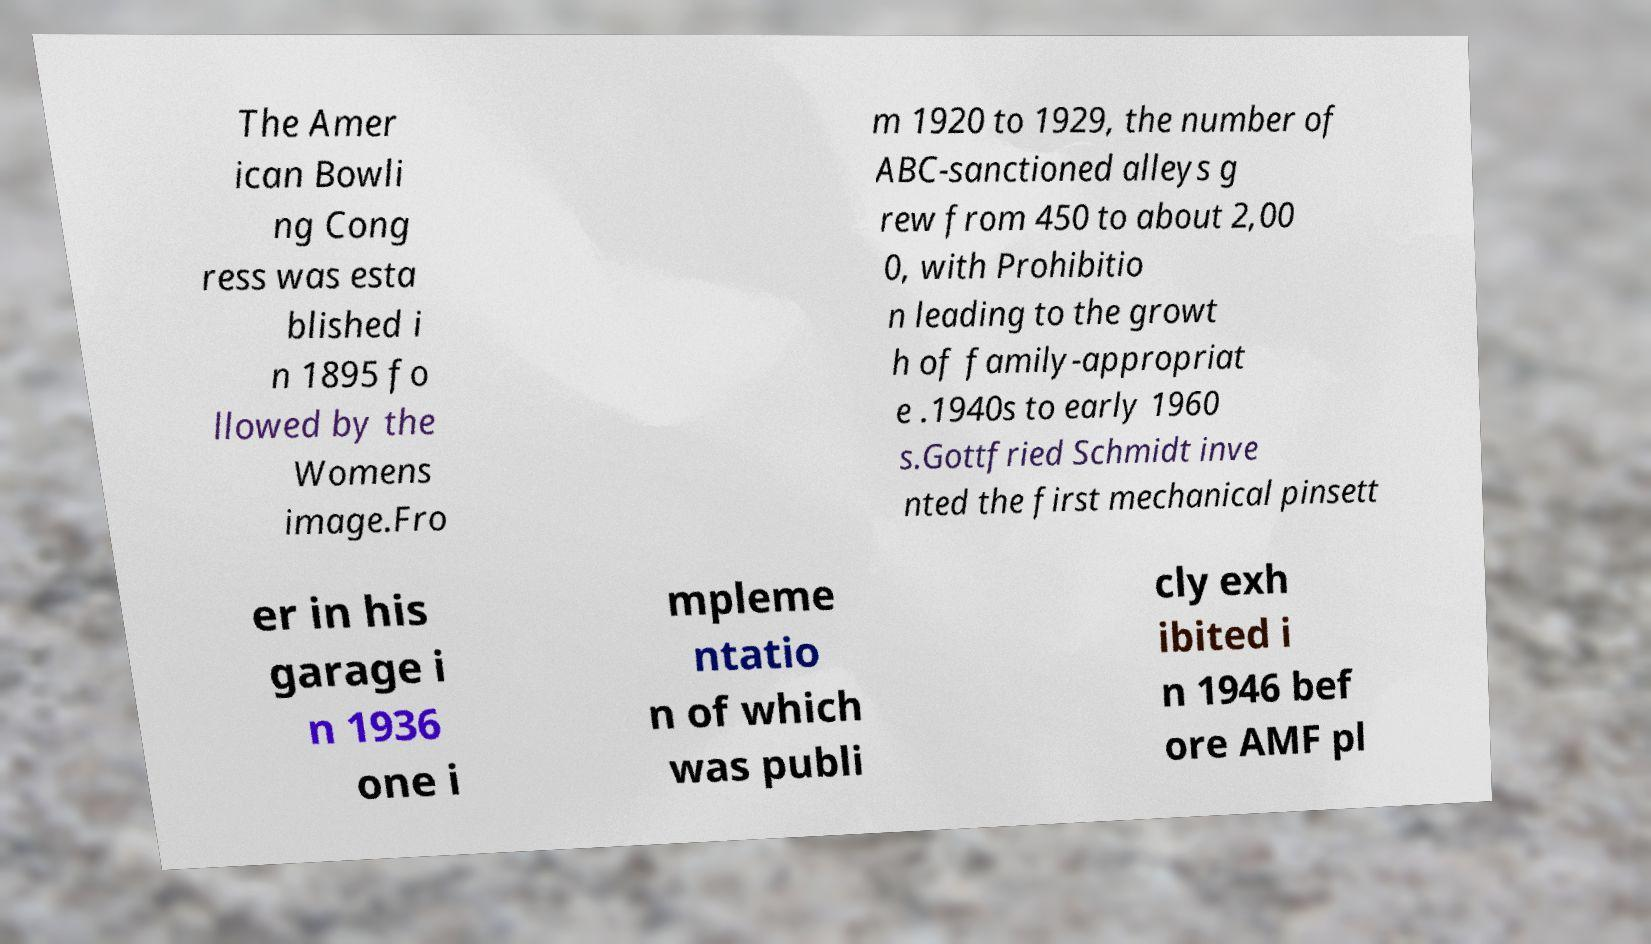I need the written content from this picture converted into text. Can you do that? The Amer ican Bowli ng Cong ress was esta blished i n 1895 fo llowed by the Womens image.Fro m 1920 to 1929, the number of ABC-sanctioned alleys g rew from 450 to about 2,00 0, with Prohibitio n leading to the growt h of family-appropriat e .1940s to early 1960 s.Gottfried Schmidt inve nted the first mechanical pinsett er in his garage i n 1936 one i mpleme ntatio n of which was publi cly exh ibited i n 1946 bef ore AMF pl 